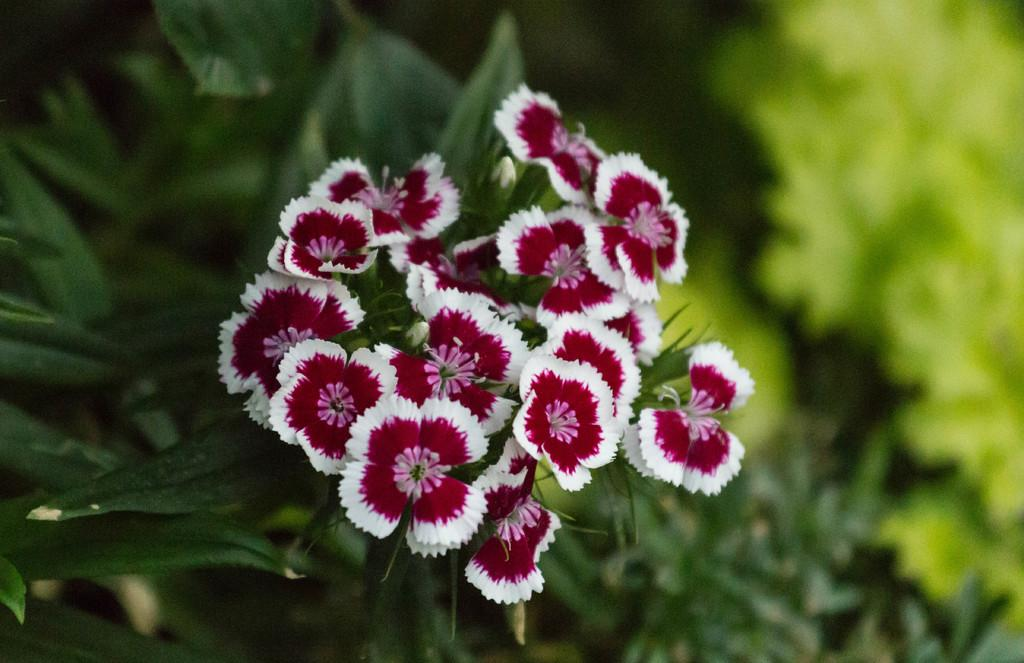What type of plants can be seen in the image? There are plants with flowers in the image. Can you describe the appearance of the right side of the image? The right side of the image is blurred. What is the taste of the butter on the edge of the image? There is no butter present in the image, so it cannot be tasted or described. 